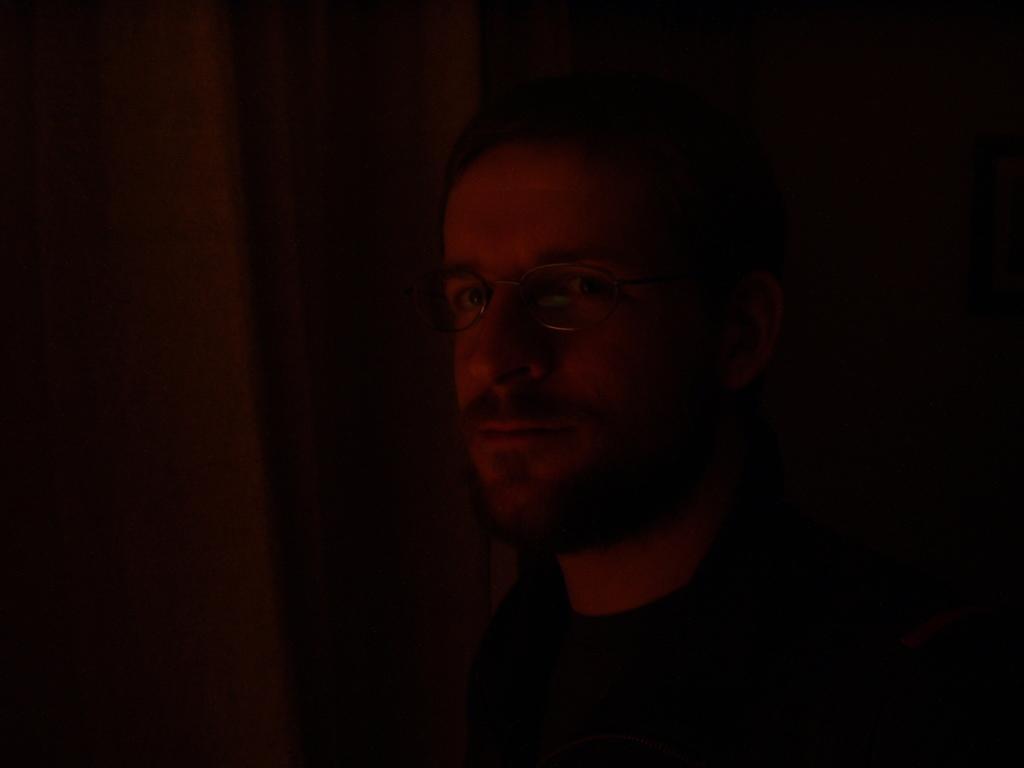In one or two sentences, can you explain what this image depicts? In this image I can see a man in the dark. This man is facing towards the left side and looking at the picture. 